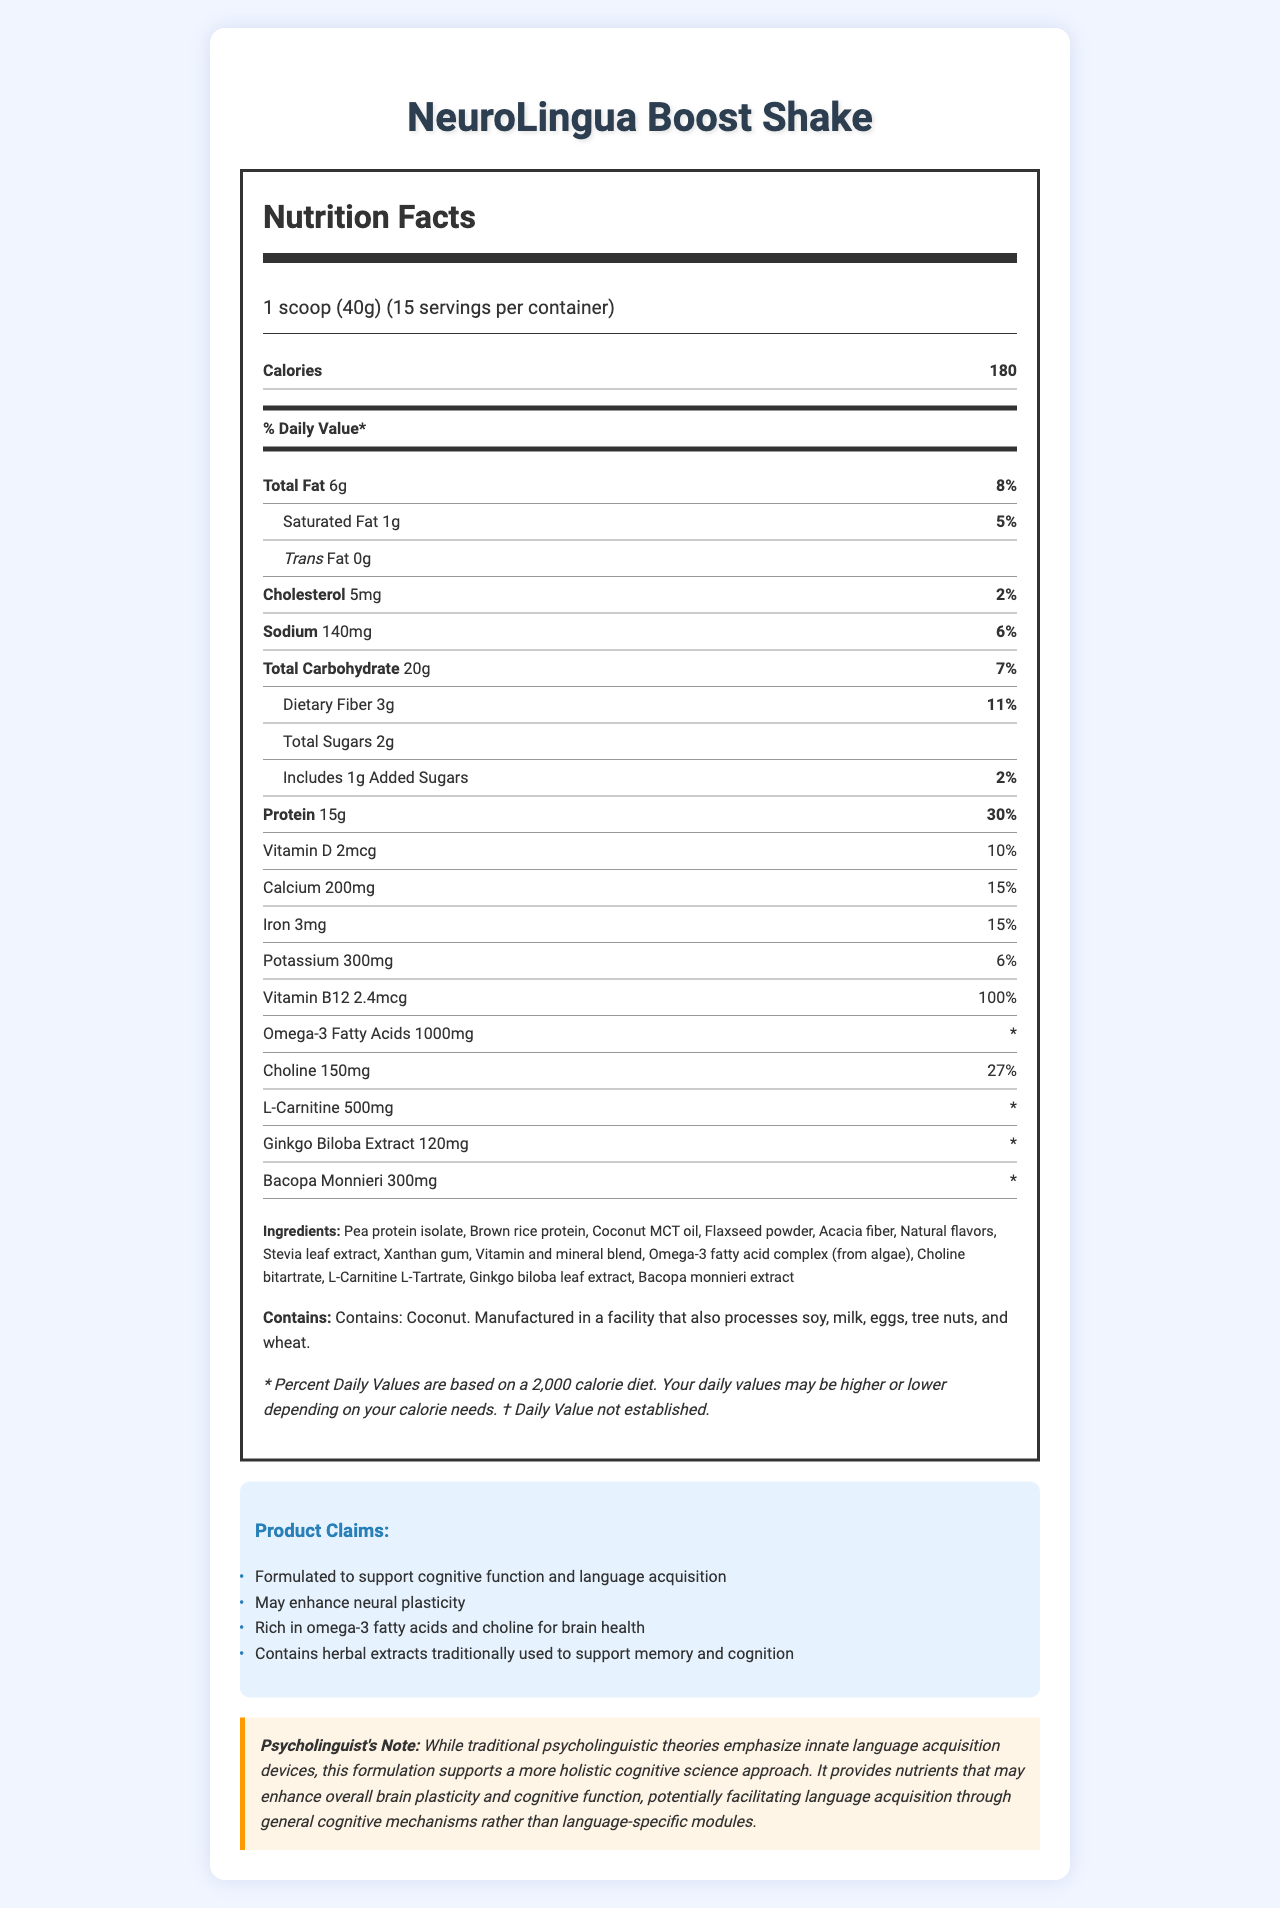what is the serving size for NeuroLingua Boost Shake? The document specifies that the serving size is 1 scoop, which weighs 40 grams.
Answer: 1 scoop (40g) how many servings are in one container? The document lists the number of servings per container as 15.
Answer: 15 what is the amount of protein per serving? The amount of protein per serving is mentioned as 15 grams.
Answer: 15g how much omega-3 fatty acids does one serving contain? According to the document, one serving contains 1000 milligrams of omega-3 fatty acids.
Answer: 1000mg what are the main herbal extracts in this shake? The document lists Ginkgo biloba leaf extract and Bacopa monnieri extract as the main herbal extracts.
Answer: Ginkgo biloba extract and Bacopa monnieri extract which vitamin in the shake has the highest percent daily value? A. Vitamin D B. Calcium C. Vitamin B12 The percent daily value of Vitamin B12 is listed as 100%, which is the highest among the vitamins provided.
Answer: C. Vitamin B12 how many grams of dietary fiber are in one serving? The document states that there are 3 grams of dietary fiber per serving.
Answer: 3g which nutrient has a daily value that is marked with an asterisk (*)? A. Omega-3 Fatty Acids B. Protein C. Vitamin D D. Iron The document indicates that the daily value for Omega-3 fatty acids is marked with an asterisk (*).
Answer: A. Omega-3 Fatty Acids does the shake contain any trans fat? The document clearly mentions that the trans fat amount is 0 grams.
Answer: No summarize the main purpose of the "NeuroLingua Boost Shake." The "NeuroLingua Boost Shake" is formulated to support brain health and cognitive functions through a blend of proteins, omega-3 fatty acids, vitamins, minerals, and herbal extracts. It aims to enhance neural plasticity and language acquisition. The document provides full nutrition facts, ingredient details, and claim statements about its benefits.
Answer: This document describes the "NeuroLingua Boost Shake," a meal replacement shake designed to support cognitive function, neural plasticity, and language acquisition. It provides detailed nutritional information, lists ingredients, claim statements, and includes a psycholinguist's note that aligns with cognitive science for enhanced brain health and language skills. is this product suitable for someone with a soy allergy? The document mentions that it is manufactured in a facility that also processes soy, but it does not specify whether the product itself contains soy.
Answer: Not enough information what is the total amount of sugars (including added sugars) in one serving? The document lists 2 grams of total sugars per serving, and 1 gram of these as added sugars, meaning the total amount of sugar is 2 grams.
Answer: 2g what is the allergen statement for this shake? The document specifies that the shake contains coconut and is made in a facility that also processes soy, milk, eggs, tree nuts, and wheat.
Answer: Contains: Coconut. Manufactured in a facility that also processes soy, milk, eggs, tree nuts, and wheat. how much choline is in each serving, and what is its daily value? The document reports that each serving contains 150 milligrams of choline, which is 27% of the daily value.
Answer: 150mg, 27% what is the main claim about omega-3 fatty acids in this shake? One of the claim statements lists the shake as being rich in omega-3 fatty acids and choline, which are beneficial for brain health.
Answer: Rich in omega-3 fatty acids and choline for brain health is Ginkgo Biloba Extract dosage in each serving? The document lists that each serving of the shake contains 120 milligrams of Ginkgo biloba extract.
Answer: 120mg 